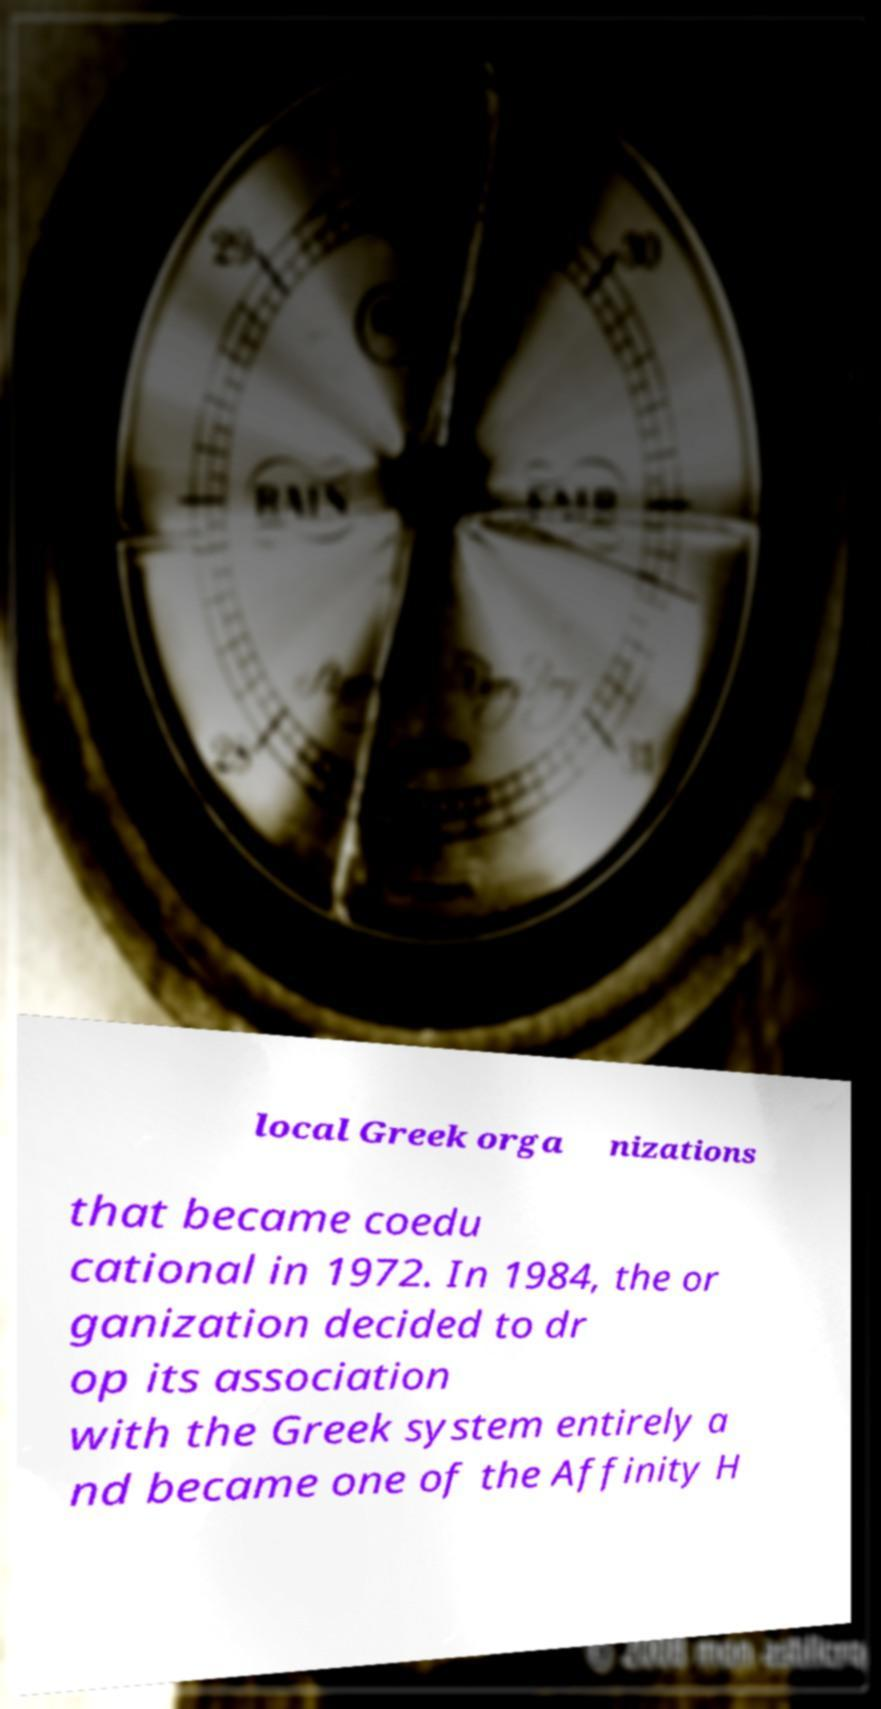Can you read and provide the text displayed in the image?This photo seems to have some interesting text. Can you extract and type it out for me? local Greek orga nizations that became coedu cational in 1972. In 1984, the or ganization decided to dr op its association with the Greek system entirely a nd became one of the Affinity H 